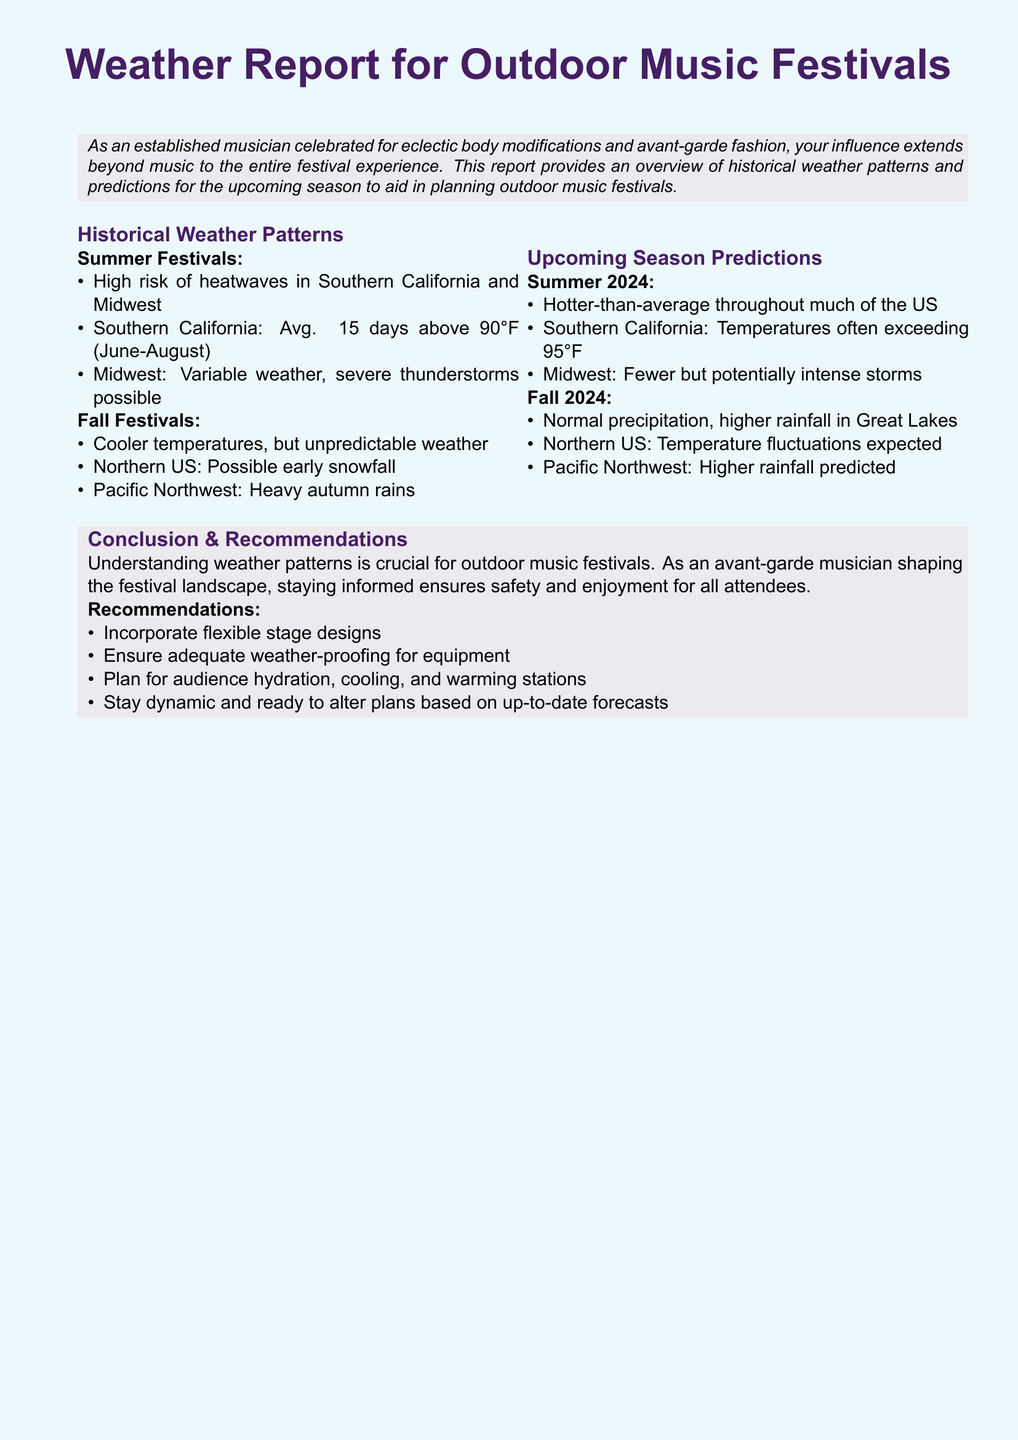What is the average number of days above 90°F in Southern California? The document states that Southern California has an average of 15 days above 90°F from June to August.
Answer: 15 days What weather pattern is associated with Midwest summer festivals? The document mentions that Midwest summer festivals have variable weather and possibly severe thunderstorms.
Answer: Severe thunderstorms What is predicted for summer 2024 in Southern California? The document states that Southern California is expected to have temperatures often exceeding 95°F in summer 2024.
Answer: Exceeding 95°F What will be the temperature trend in Fall 2024 for the Northern US? The document indicates temperature fluctuations are expected in the Northern US during Fall 2024.
Answer: Fluctuations What is a recommendation for planning outdoor music festivals? The document suggests ensuring adequate weather-proofing for equipment as a recommendation.
Answer: Weather-proofing for equipment What type of precipitation is expected in Fall 2024 for the Great Lakes? The document mentions normal precipitation with higher rainfall predicted in the Great Lakes for Fall 2024.
Answer: Higher rainfall Which region is highlighted for possible early snowfall in fall festivals? The document specifically states that the Northern US may experience possible early snowfall.
Answer: Northern US What are summer festivals at higher risk for in Southern California? The document identifies that summer festivals in Southern California are at high risk for heatwaves.
Answer: Heatwaves 